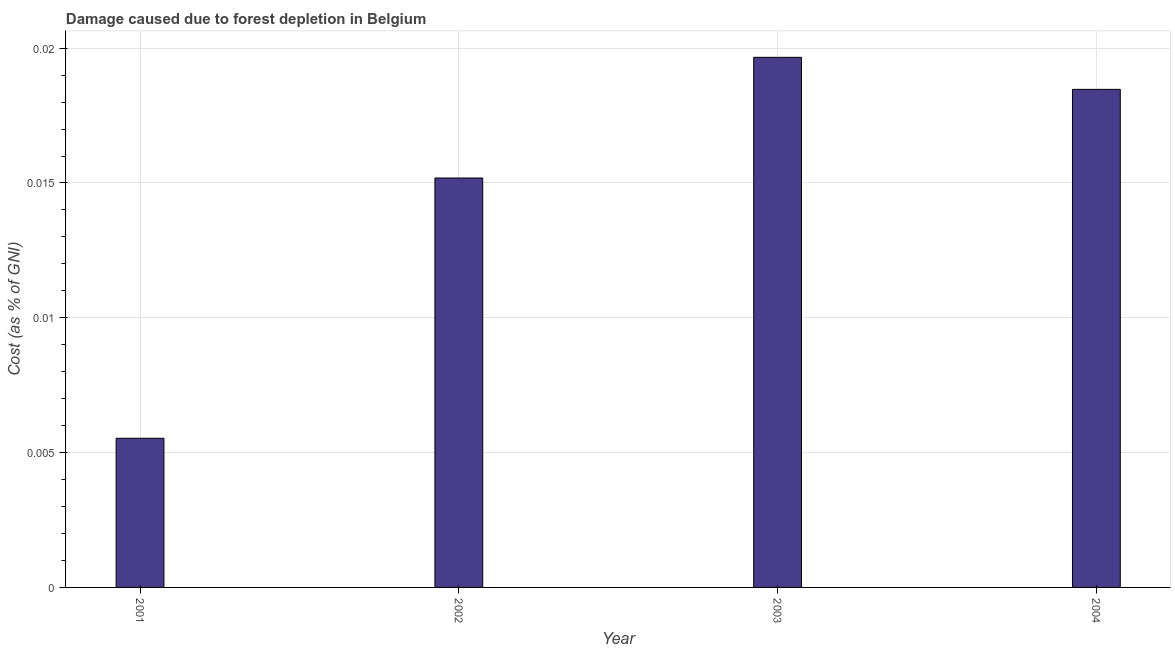Does the graph contain any zero values?
Provide a succinct answer. No. Does the graph contain grids?
Offer a terse response. Yes. What is the title of the graph?
Offer a terse response. Damage caused due to forest depletion in Belgium. What is the label or title of the X-axis?
Provide a short and direct response. Year. What is the label or title of the Y-axis?
Provide a succinct answer. Cost (as % of GNI). What is the damage caused due to forest depletion in 2001?
Give a very brief answer. 0.01. Across all years, what is the maximum damage caused due to forest depletion?
Your response must be concise. 0.02. Across all years, what is the minimum damage caused due to forest depletion?
Keep it short and to the point. 0.01. In which year was the damage caused due to forest depletion minimum?
Offer a terse response. 2001. What is the sum of the damage caused due to forest depletion?
Keep it short and to the point. 0.06. What is the difference between the damage caused due to forest depletion in 2001 and 2004?
Provide a short and direct response. -0.01. What is the average damage caused due to forest depletion per year?
Your answer should be very brief. 0.01. What is the median damage caused due to forest depletion?
Offer a very short reply. 0.02. Do a majority of the years between 2001 and 2004 (inclusive) have damage caused due to forest depletion greater than 0.013 %?
Keep it short and to the point. Yes. What is the ratio of the damage caused due to forest depletion in 2003 to that in 2004?
Your response must be concise. 1.06. Is the difference between the damage caused due to forest depletion in 2002 and 2004 greater than the difference between any two years?
Provide a succinct answer. No. Is the sum of the damage caused due to forest depletion in 2001 and 2003 greater than the maximum damage caused due to forest depletion across all years?
Your answer should be compact. Yes. What is the difference between the highest and the lowest damage caused due to forest depletion?
Your answer should be very brief. 0.01. How many years are there in the graph?
Ensure brevity in your answer.  4. What is the difference between two consecutive major ticks on the Y-axis?
Your answer should be very brief. 0.01. Are the values on the major ticks of Y-axis written in scientific E-notation?
Ensure brevity in your answer.  No. What is the Cost (as % of GNI) of 2001?
Your answer should be very brief. 0.01. What is the Cost (as % of GNI) of 2002?
Your answer should be very brief. 0.02. What is the Cost (as % of GNI) of 2003?
Offer a terse response. 0.02. What is the Cost (as % of GNI) in 2004?
Offer a very short reply. 0.02. What is the difference between the Cost (as % of GNI) in 2001 and 2002?
Ensure brevity in your answer.  -0.01. What is the difference between the Cost (as % of GNI) in 2001 and 2003?
Provide a short and direct response. -0.01. What is the difference between the Cost (as % of GNI) in 2001 and 2004?
Your answer should be compact. -0.01. What is the difference between the Cost (as % of GNI) in 2002 and 2003?
Provide a short and direct response. -0. What is the difference between the Cost (as % of GNI) in 2002 and 2004?
Give a very brief answer. -0. What is the difference between the Cost (as % of GNI) in 2003 and 2004?
Keep it short and to the point. 0. What is the ratio of the Cost (as % of GNI) in 2001 to that in 2002?
Make the answer very short. 0.36. What is the ratio of the Cost (as % of GNI) in 2001 to that in 2003?
Offer a terse response. 0.28. What is the ratio of the Cost (as % of GNI) in 2001 to that in 2004?
Ensure brevity in your answer.  0.3. What is the ratio of the Cost (as % of GNI) in 2002 to that in 2003?
Ensure brevity in your answer.  0.77. What is the ratio of the Cost (as % of GNI) in 2002 to that in 2004?
Your answer should be compact. 0.82. What is the ratio of the Cost (as % of GNI) in 2003 to that in 2004?
Provide a short and direct response. 1.06. 